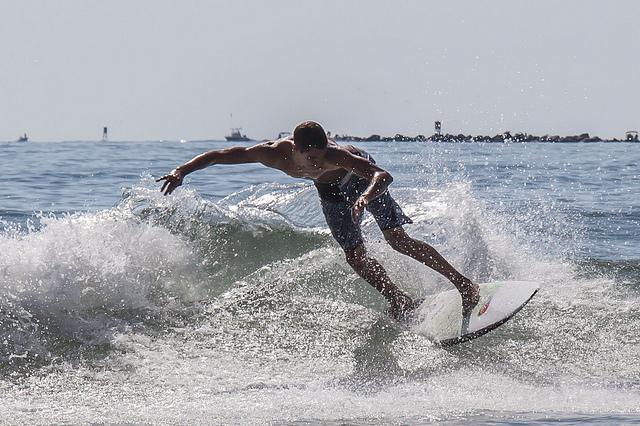Why is he leaning forward?
Indicate the correct response and explain using: 'Answer: answer
Rationale: rationale.'
Options: Is falling, maintaining balance, was surprised, bad back. Answer: maintaining balance.
Rationale: A surfer is on a surfboard. people lean to gain balance. 